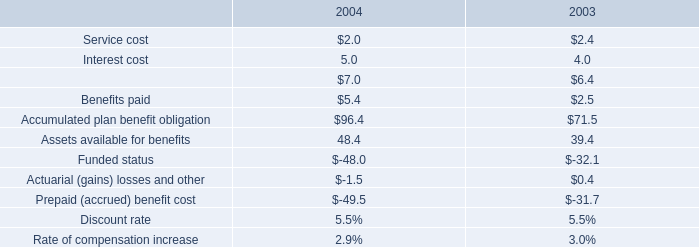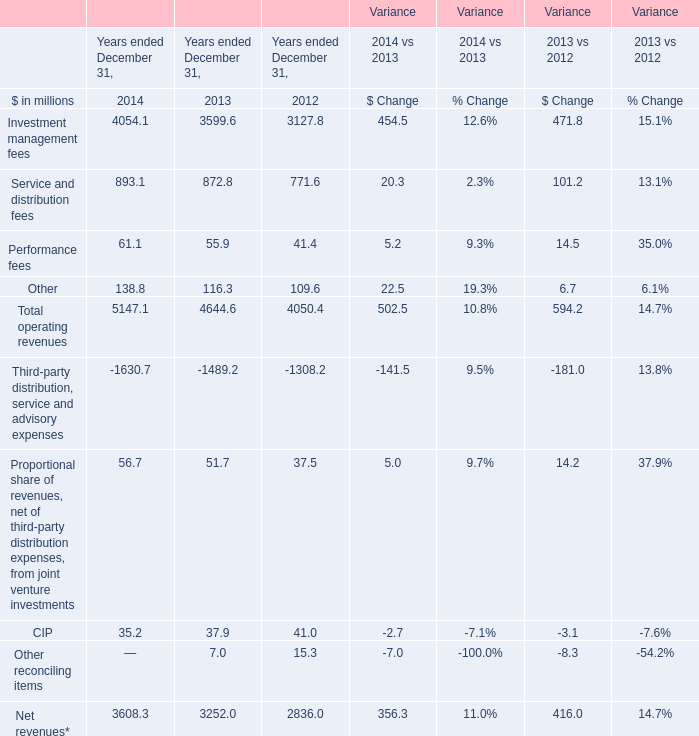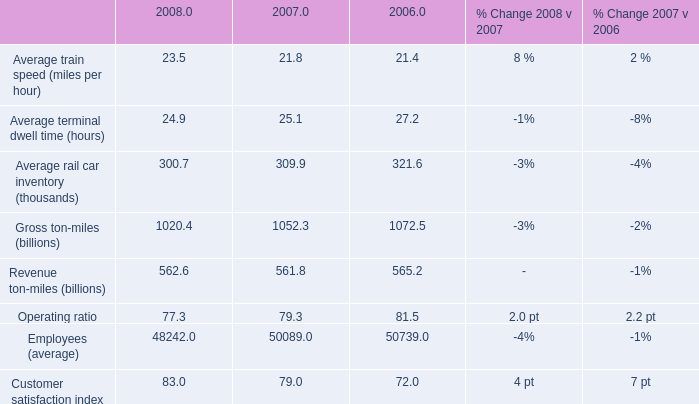What is the ratio of Service and distribution fees to Total operating revenues in 2012? 
Computations: (771.6 / 4050.4)
Answer: 0.1905. 